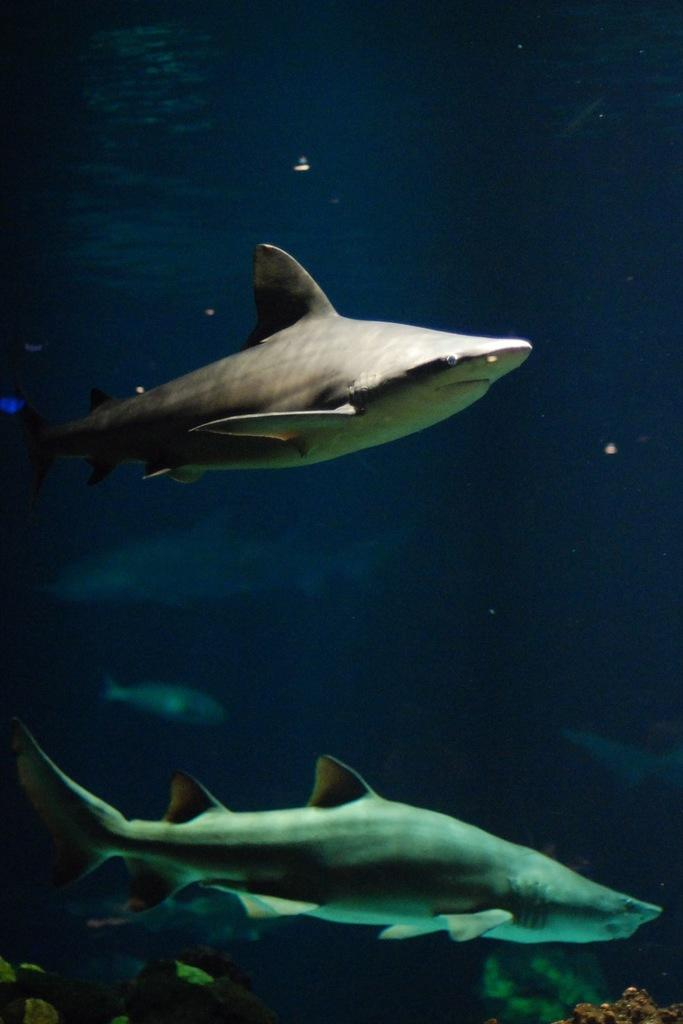What body of water is present in the image? There is a river in the image. What can be found living in the river? There are fishes in the river. Are there any plants visible in the river? Yes, there are water plants in the river. How many crows are perched on the hill in the image? There is no hill or crow present in the image. 